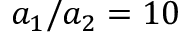Convert formula to latex. <formula><loc_0><loc_0><loc_500><loc_500>a _ { 1 } / a _ { 2 } = 1 0</formula> 